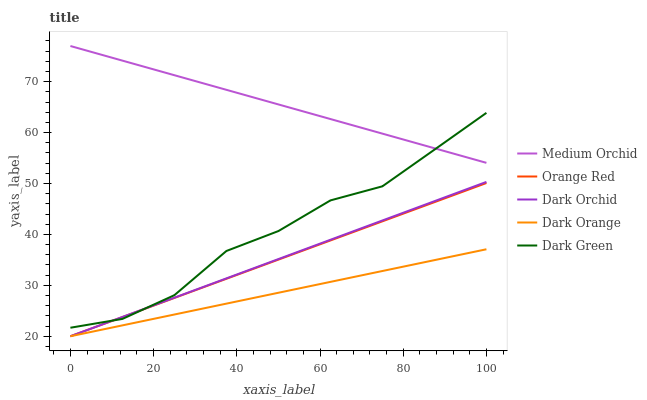Does Dark Orange have the minimum area under the curve?
Answer yes or no. Yes. Does Medium Orchid have the maximum area under the curve?
Answer yes or no. Yes. Does Orange Red have the minimum area under the curve?
Answer yes or no. No. Does Orange Red have the maximum area under the curve?
Answer yes or no. No. Is Dark Orange the smoothest?
Answer yes or no. Yes. Is Dark Green the roughest?
Answer yes or no. Yes. Is Medium Orchid the smoothest?
Answer yes or no. No. Is Medium Orchid the roughest?
Answer yes or no. No. Does Dark Orange have the lowest value?
Answer yes or no. Yes. Does Medium Orchid have the lowest value?
Answer yes or no. No. Does Medium Orchid have the highest value?
Answer yes or no. Yes. Does Orange Red have the highest value?
Answer yes or no. No. Is Dark Orchid less than Medium Orchid?
Answer yes or no. Yes. Is Medium Orchid greater than Dark Orange?
Answer yes or no. Yes. Does Dark Green intersect Orange Red?
Answer yes or no. Yes. Is Dark Green less than Orange Red?
Answer yes or no. No. Is Dark Green greater than Orange Red?
Answer yes or no. No. Does Dark Orchid intersect Medium Orchid?
Answer yes or no. No. 